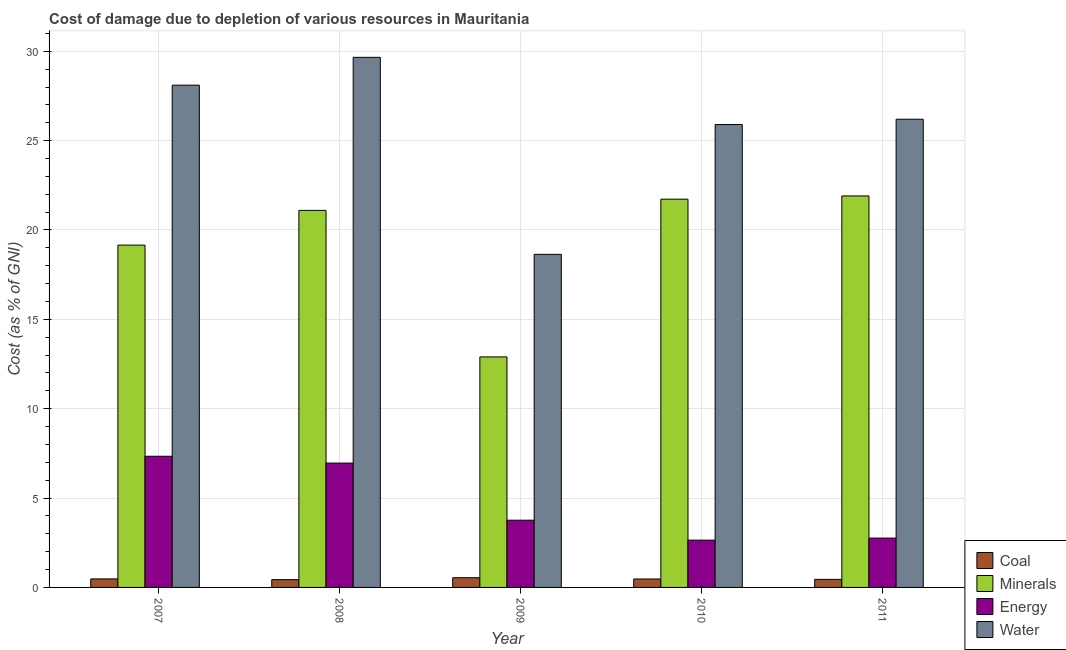How many different coloured bars are there?
Keep it short and to the point. 4. Are the number of bars on each tick of the X-axis equal?
Give a very brief answer. Yes. What is the label of the 1st group of bars from the left?
Your answer should be compact. 2007. In how many cases, is the number of bars for a given year not equal to the number of legend labels?
Provide a short and direct response. 0. What is the cost of damage due to depletion of energy in 2010?
Make the answer very short. 2.65. Across all years, what is the maximum cost of damage due to depletion of water?
Your response must be concise. 29.66. Across all years, what is the minimum cost of damage due to depletion of coal?
Your answer should be compact. 0.44. In which year was the cost of damage due to depletion of coal minimum?
Ensure brevity in your answer.  2008. What is the total cost of damage due to depletion of energy in the graph?
Give a very brief answer. 23.47. What is the difference between the cost of damage due to depletion of water in 2009 and that in 2010?
Provide a succinct answer. -7.26. What is the difference between the cost of damage due to depletion of energy in 2009 and the cost of damage due to depletion of minerals in 2007?
Your answer should be compact. -3.58. What is the average cost of damage due to depletion of energy per year?
Your response must be concise. 4.69. In the year 2008, what is the difference between the cost of damage due to depletion of minerals and cost of damage due to depletion of coal?
Your answer should be very brief. 0. In how many years, is the cost of damage due to depletion of minerals greater than 13 %?
Your answer should be compact. 4. What is the ratio of the cost of damage due to depletion of minerals in 2007 to that in 2010?
Offer a very short reply. 0.88. What is the difference between the highest and the second highest cost of damage due to depletion of minerals?
Your answer should be compact. 0.18. What is the difference between the highest and the lowest cost of damage due to depletion of energy?
Keep it short and to the point. 4.69. In how many years, is the cost of damage due to depletion of water greater than the average cost of damage due to depletion of water taken over all years?
Keep it short and to the point. 4. Is the sum of the cost of damage due to depletion of coal in 2009 and 2010 greater than the maximum cost of damage due to depletion of water across all years?
Keep it short and to the point. Yes. Is it the case that in every year, the sum of the cost of damage due to depletion of water and cost of damage due to depletion of energy is greater than the sum of cost of damage due to depletion of coal and cost of damage due to depletion of minerals?
Offer a very short reply. Yes. What does the 2nd bar from the left in 2011 represents?
Keep it short and to the point. Minerals. What does the 3rd bar from the right in 2011 represents?
Your answer should be compact. Minerals. How many bars are there?
Your response must be concise. 20. Are all the bars in the graph horizontal?
Provide a short and direct response. No. How many years are there in the graph?
Give a very brief answer. 5. What is the difference between two consecutive major ticks on the Y-axis?
Your answer should be very brief. 5. Does the graph contain grids?
Offer a very short reply. Yes. Where does the legend appear in the graph?
Keep it short and to the point. Bottom right. How many legend labels are there?
Offer a very short reply. 4. What is the title of the graph?
Offer a very short reply. Cost of damage due to depletion of various resources in Mauritania . What is the label or title of the Y-axis?
Offer a terse response. Cost (as % of GNI). What is the Cost (as % of GNI) of Coal in 2007?
Keep it short and to the point. 0.48. What is the Cost (as % of GNI) in Minerals in 2007?
Give a very brief answer. 19.15. What is the Cost (as % of GNI) in Energy in 2007?
Offer a terse response. 7.34. What is the Cost (as % of GNI) in Water in 2007?
Give a very brief answer. 28.1. What is the Cost (as % of GNI) in Coal in 2008?
Give a very brief answer. 0.44. What is the Cost (as % of GNI) of Minerals in 2008?
Keep it short and to the point. 21.1. What is the Cost (as % of GNI) in Energy in 2008?
Your response must be concise. 6.96. What is the Cost (as % of GNI) in Water in 2008?
Give a very brief answer. 29.66. What is the Cost (as % of GNI) of Coal in 2009?
Offer a very short reply. 0.54. What is the Cost (as % of GNI) in Minerals in 2009?
Keep it short and to the point. 12.9. What is the Cost (as % of GNI) in Energy in 2009?
Keep it short and to the point. 3.76. What is the Cost (as % of GNI) of Water in 2009?
Your answer should be compact. 18.64. What is the Cost (as % of GNI) of Coal in 2010?
Make the answer very short. 0.47. What is the Cost (as % of GNI) in Minerals in 2010?
Provide a short and direct response. 21.73. What is the Cost (as % of GNI) of Energy in 2010?
Provide a succinct answer. 2.65. What is the Cost (as % of GNI) of Water in 2010?
Provide a short and direct response. 25.9. What is the Cost (as % of GNI) of Coal in 2011?
Give a very brief answer. 0.45. What is the Cost (as % of GNI) in Minerals in 2011?
Your answer should be very brief. 21.91. What is the Cost (as % of GNI) of Energy in 2011?
Offer a very short reply. 2.76. What is the Cost (as % of GNI) in Water in 2011?
Your response must be concise. 26.2. Across all years, what is the maximum Cost (as % of GNI) in Coal?
Your answer should be very brief. 0.54. Across all years, what is the maximum Cost (as % of GNI) of Minerals?
Your answer should be compact. 21.91. Across all years, what is the maximum Cost (as % of GNI) in Energy?
Your answer should be compact. 7.34. Across all years, what is the maximum Cost (as % of GNI) in Water?
Offer a terse response. 29.66. Across all years, what is the minimum Cost (as % of GNI) of Coal?
Offer a terse response. 0.44. Across all years, what is the minimum Cost (as % of GNI) in Minerals?
Provide a short and direct response. 12.9. Across all years, what is the minimum Cost (as % of GNI) in Energy?
Your response must be concise. 2.65. Across all years, what is the minimum Cost (as % of GNI) of Water?
Your answer should be compact. 18.64. What is the total Cost (as % of GNI) of Coal in the graph?
Offer a terse response. 2.38. What is the total Cost (as % of GNI) in Minerals in the graph?
Provide a succinct answer. 96.78. What is the total Cost (as % of GNI) in Energy in the graph?
Keep it short and to the point. 23.47. What is the total Cost (as % of GNI) of Water in the graph?
Keep it short and to the point. 128.5. What is the difference between the Cost (as % of GNI) of Coal in 2007 and that in 2008?
Give a very brief answer. 0.04. What is the difference between the Cost (as % of GNI) in Minerals in 2007 and that in 2008?
Your answer should be compact. -1.95. What is the difference between the Cost (as % of GNI) in Energy in 2007 and that in 2008?
Give a very brief answer. 0.38. What is the difference between the Cost (as % of GNI) of Water in 2007 and that in 2008?
Your answer should be compact. -1.56. What is the difference between the Cost (as % of GNI) in Coal in 2007 and that in 2009?
Make the answer very short. -0.07. What is the difference between the Cost (as % of GNI) in Minerals in 2007 and that in 2009?
Your answer should be compact. 6.25. What is the difference between the Cost (as % of GNI) of Energy in 2007 and that in 2009?
Offer a terse response. 3.58. What is the difference between the Cost (as % of GNI) in Water in 2007 and that in 2009?
Your response must be concise. 9.47. What is the difference between the Cost (as % of GNI) of Coal in 2007 and that in 2010?
Your answer should be compact. 0. What is the difference between the Cost (as % of GNI) of Minerals in 2007 and that in 2010?
Give a very brief answer. -2.57. What is the difference between the Cost (as % of GNI) in Energy in 2007 and that in 2010?
Offer a terse response. 4.69. What is the difference between the Cost (as % of GNI) of Water in 2007 and that in 2010?
Ensure brevity in your answer.  2.2. What is the difference between the Cost (as % of GNI) of Coal in 2007 and that in 2011?
Your answer should be very brief. 0.03. What is the difference between the Cost (as % of GNI) of Minerals in 2007 and that in 2011?
Ensure brevity in your answer.  -2.75. What is the difference between the Cost (as % of GNI) of Energy in 2007 and that in 2011?
Ensure brevity in your answer.  4.58. What is the difference between the Cost (as % of GNI) in Water in 2007 and that in 2011?
Keep it short and to the point. 1.91. What is the difference between the Cost (as % of GNI) in Coal in 2008 and that in 2009?
Your response must be concise. -0.11. What is the difference between the Cost (as % of GNI) in Minerals in 2008 and that in 2009?
Make the answer very short. 8.2. What is the difference between the Cost (as % of GNI) of Energy in 2008 and that in 2009?
Your answer should be very brief. 3.2. What is the difference between the Cost (as % of GNI) in Water in 2008 and that in 2009?
Keep it short and to the point. 11.02. What is the difference between the Cost (as % of GNI) of Coal in 2008 and that in 2010?
Make the answer very short. -0.04. What is the difference between the Cost (as % of GNI) in Minerals in 2008 and that in 2010?
Provide a short and direct response. -0.63. What is the difference between the Cost (as % of GNI) in Energy in 2008 and that in 2010?
Your answer should be compact. 4.31. What is the difference between the Cost (as % of GNI) of Water in 2008 and that in 2010?
Your response must be concise. 3.76. What is the difference between the Cost (as % of GNI) of Coal in 2008 and that in 2011?
Your response must be concise. -0.02. What is the difference between the Cost (as % of GNI) of Minerals in 2008 and that in 2011?
Your answer should be very brief. -0.81. What is the difference between the Cost (as % of GNI) in Energy in 2008 and that in 2011?
Offer a very short reply. 4.2. What is the difference between the Cost (as % of GNI) in Water in 2008 and that in 2011?
Your answer should be very brief. 3.46. What is the difference between the Cost (as % of GNI) in Coal in 2009 and that in 2010?
Your answer should be compact. 0.07. What is the difference between the Cost (as % of GNI) of Minerals in 2009 and that in 2010?
Your response must be concise. -8.83. What is the difference between the Cost (as % of GNI) of Energy in 2009 and that in 2010?
Offer a very short reply. 1.12. What is the difference between the Cost (as % of GNI) of Water in 2009 and that in 2010?
Your response must be concise. -7.26. What is the difference between the Cost (as % of GNI) of Coal in 2009 and that in 2011?
Offer a very short reply. 0.09. What is the difference between the Cost (as % of GNI) of Minerals in 2009 and that in 2011?
Give a very brief answer. -9.01. What is the difference between the Cost (as % of GNI) of Water in 2009 and that in 2011?
Give a very brief answer. -7.56. What is the difference between the Cost (as % of GNI) of Coal in 2010 and that in 2011?
Provide a succinct answer. 0.02. What is the difference between the Cost (as % of GNI) in Minerals in 2010 and that in 2011?
Provide a succinct answer. -0.18. What is the difference between the Cost (as % of GNI) of Energy in 2010 and that in 2011?
Offer a very short reply. -0.11. What is the difference between the Cost (as % of GNI) in Water in 2010 and that in 2011?
Provide a short and direct response. -0.3. What is the difference between the Cost (as % of GNI) of Coal in 2007 and the Cost (as % of GNI) of Minerals in 2008?
Offer a very short reply. -20.62. What is the difference between the Cost (as % of GNI) in Coal in 2007 and the Cost (as % of GNI) in Energy in 2008?
Ensure brevity in your answer.  -6.48. What is the difference between the Cost (as % of GNI) of Coal in 2007 and the Cost (as % of GNI) of Water in 2008?
Ensure brevity in your answer.  -29.19. What is the difference between the Cost (as % of GNI) in Minerals in 2007 and the Cost (as % of GNI) in Energy in 2008?
Provide a succinct answer. 12.2. What is the difference between the Cost (as % of GNI) in Minerals in 2007 and the Cost (as % of GNI) in Water in 2008?
Ensure brevity in your answer.  -10.51. What is the difference between the Cost (as % of GNI) in Energy in 2007 and the Cost (as % of GNI) in Water in 2008?
Your answer should be compact. -22.32. What is the difference between the Cost (as % of GNI) of Coal in 2007 and the Cost (as % of GNI) of Minerals in 2009?
Give a very brief answer. -12.42. What is the difference between the Cost (as % of GNI) of Coal in 2007 and the Cost (as % of GNI) of Energy in 2009?
Your answer should be compact. -3.29. What is the difference between the Cost (as % of GNI) in Coal in 2007 and the Cost (as % of GNI) in Water in 2009?
Give a very brief answer. -18.16. What is the difference between the Cost (as % of GNI) in Minerals in 2007 and the Cost (as % of GNI) in Energy in 2009?
Make the answer very short. 15.39. What is the difference between the Cost (as % of GNI) in Minerals in 2007 and the Cost (as % of GNI) in Water in 2009?
Ensure brevity in your answer.  0.52. What is the difference between the Cost (as % of GNI) of Energy in 2007 and the Cost (as % of GNI) of Water in 2009?
Your answer should be compact. -11.3. What is the difference between the Cost (as % of GNI) in Coal in 2007 and the Cost (as % of GNI) in Minerals in 2010?
Make the answer very short. -21.25. What is the difference between the Cost (as % of GNI) in Coal in 2007 and the Cost (as % of GNI) in Energy in 2010?
Make the answer very short. -2.17. What is the difference between the Cost (as % of GNI) of Coal in 2007 and the Cost (as % of GNI) of Water in 2010?
Give a very brief answer. -25.42. What is the difference between the Cost (as % of GNI) in Minerals in 2007 and the Cost (as % of GNI) in Energy in 2010?
Provide a short and direct response. 16.51. What is the difference between the Cost (as % of GNI) in Minerals in 2007 and the Cost (as % of GNI) in Water in 2010?
Provide a short and direct response. -6.75. What is the difference between the Cost (as % of GNI) of Energy in 2007 and the Cost (as % of GNI) of Water in 2010?
Make the answer very short. -18.56. What is the difference between the Cost (as % of GNI) in Coal in 2007 and the Cost (as % of GNI) in Minerals in 2011?
Provide a short and direct response. -21.43. What is the difference between the Cost (as % of GNI) of Coal in 2007 and the Cost (as % of GNI) of Energy in 2011?
Provide a short and direct response. -2.28. What is the difference between the Cost (as % of GNI) of Coal in 2007 and the Cost (as % of GNI) of Water in 2011?
Provide a short and direct response. -25.72. What is the difference between the Cost (as % of GNI) in Minerals in 2007 and the Cost (as % of GNI) in Energy in 2011?
Make the answer very short. 16.39. What is the difference between the Cost (as % of GNI) of Minerals in 2007 and the Cost (as % of GNI) of Water in 2011?
Provide a short and direct response. -7.04. What is the difference between the Cost (as % of GNI) in Energy in 2007 and the Cost (as % of GNI) in Water in 2011?
Offer a very short reply. -18.86. What is the difference between the Cost (as % of GNI) in Coal in 2008 and the Cost (as % of GNI) in Minerals in 2009?
Give a very brief answer. -12.46. What is the difference between the Cost (as % of GNI) of Coal in 2008 and the Cost (as % of GNI) of Energy in 2009?
Give a very brief answer. -3.33. What is the difference between the Cost (as % of GNI) of Coal in 2008 and the Cost (as % of GNI) of Water in 2009?
Your answer should be very brief. -18.2. What is the difference between the Cost (as % of GNI) of Minerals in 2008 and the Cost (as % of GNI) of Energy in 2009?
Offer a very short reply. 17.34. What is the difference between the Cost (as % of GNI) of Minerals in 2008 and the Cost (as % of GNI) of Water in 2009?
Keep it short and to the point. 2.46. What is the difference between the Cost (as % of GNI) of Energy in 2008 and the Cost (as % of GNI) of Water in 2009?
Make the answer very short. -11.68. What is the difference between the Cost (as % of GNI) in Coal in 2008 and the Cost (as % of GNI) in Minerals in 2010?
Your answer should be compact. -21.29. What is the difference between the Cost (as % of GNI) in Coal in 2008 and the Cost (as % of GNI) in Energy in 2010?
Your answer should be very brief. -2.21. What is the difference between the Cost (as % of GNI) of Coal in 2008 and the Cost (as % of GNI) of Water in 2010?
Make the answer very short. -25.47. What is the difference between the Cost (as % of GNI) in Minerals in 2008 and the Cost (as % of GNI) in Energy in 2010?
Offer a terse response. 18.45. What is the difference between the Cost (as % of GNI) of Minerals in 2008 and the Cost (as % of GNI) of Water in 2010?
Keep it short and to the point. -4.8. What is the difference between the Cost (as % of GNI) of Energy in 2008 and the Cost (as % of GNI) of Water in 2010?
Give a very brief answer. -18.94. What is the difference between the Cost (as % of GNI) of Coal in 2008 and the Cost (as % of GNI) of Minerals in 2011?
Your answer should be compact. -21.47. What is the difference between the Cost (as % of GNI) in Coal in 2008 and the Cost (as % of GNI) in Energy in 2011?
Keep it short and to the point. -2.33. What is the difference between the Cost (as % of GNI) of Coal in 2008 and the Cost (as % of GNI) of Water in 2011?
Give a very brief answer. -25.76. What is the difference between the Cost (as % of GNI) in Minerals in 2008 and the Cost (as % of GNI) in Energy in 2011?
Provide a short and direct response. 18.34. What is the difference between the Cost (as % of GNI) of Minerals in 2008 and the Cost (as % of GNI) of Water in 2011?
Your answer should be very brief. -5.1. What is the difference between the Cost (as % of GNI) of Energy in 2008 and the Cost (as % of GNI) of Water in 2011?
Give a very brief answer. -19.24. What is the difference between the Cost (as % of GNI) of Coal in 2009 and the Cost (as % of GNI) of Minerals in 2010?
Offer a very short reply. -21.18. What is the difference between the Cost (as % of GNI) in Coal in 2009 and the Cost (as % of GNI) in Energy in 2010?
Your answer should be compact. -2.1. What is the difference between the Cost (as % of GNI) in Coal in 2009 and the Cost (as % of GNI) in Water in 2010?
Give a very brief answer. -25.36. What is the difference between the Cost (as % of GNI) of Minerals in 2009 and the Cost (as % of GNI) of Energy in 2010?
Make the answer very short. 10.25. What is the difference between the Cost (as % of GNI) of Minerals in 2009 and the Cost (as % of GNI) of Water in 2010?
Provide a short and direct response. -13. What is the difference between the Cost (as % of GNI) of Energy in 2009 and the Cost (as % of GNI) of Water in 2010?
Your response must be concise. -22.14. What is the difference between the Cost (as % of GNI) in Coal in 2009 and the Cost (as % of GNI) in Minerals in 2011?
Offer a very short reply. -21.36. What is the difference between the Cost (as % of GNI) of Coal in 2009 and the Cost (as % of GNI) of Energy in 2011?
Your answer should be very brief. -2.22. What is the difference between the Cost (as % of GNI) of Coal in 2009 and the Cost (as % of GNI) of Water in 2011?
Provide a short and direct response. -25.65. What is the difference between the Cost (as % of GNI) in Minerals in 2009 and the Cost (as % of GNI) in Energy in 2011?
Provide a succinct answer. 10.14. What is the difference between the Cost (as % of GNI) in Minerals in 2009 and the Cost (as % of GNI) in Water in 2011?
Provide a short and direct response. -13.3. What is the difference between the Cost (as % of GNI) in Energy in 2009 and the Cost (as % of GNI) in Water in 2011?
Offer a very short reply. -22.44. What is the difference between the Cost (as % of GNI) in Coal in 2010 and the Cost (as % of GNI) in Minerals in 2011?
Provide a short and direct response. -21.43. What is the difference between the Cost (as % of GNI) in Coal in 2010 and the Cost (as % of GNI) in Energy in 2011?
Make the answer very short. -2.29. What is the difference between the Cost (as % of GNI) of Coal in 2010 and the Cost (as % of GNI) of Water in 2011?
Provide a short and direct response. -25.73. What is the difference between the Cost (as % of GNI) in Minerals in 2010 and the Cost (as % of GNI) in Energy in 2011?
Provide a short and direct response. 18.96. What is the difference between the Cost (as % of GNI) in Minerals in 2010 and the Cost (as % of GNI) in Water in 2011?
Provide a short and direct response. -4.47. What is the difference between the Cost (as % of GNI) of Energy in 2010 and the Cost (as % of GNI) of Water in 2011?
Make the answer very short. -23.55. What is the average Cost (as % of GNI) in Coal per year?
Offer a terse response. 0.48. What is the average Cost (as % of GNI) of Minerals per year?
Provide a succinct answer. 19.36. What is the average Cost (as % of GNI) of Energy per year?
Your answer should be compact. 4.69. What is the average Cost (as % of GNI) in Water per year?
Make the answer very short. 25.7. In the year 2007, what is the difference between the Cost (as % of GNI) of Coal and Cost (as % of GNI) of Minerals?
Your response must be concise. -18.68. In the year 2007, what is the difference between the Cost (as % of GNI) of Coal and Cost (as % of GNI) of Energy?
Your response must be concise. -6.86. In the year 2007, what is the difference between the Cost (as % of GNI) in Coal and Cost (as % of GNI) in Water?
Ensure brevity in your answer.  -27.63. In the year 2007, what is the difference between the Cost (as % of GNI) in Minerals and Cost (as % of GNI) in Energy?
Make the answer very short. 11.81. In the year 2007, what is the difference between the Cost (as % of GNI) in Minerals and Cost (as % of GNI) in Water?
Make the answer very short. -8.95. In the year 2007, what is the difference between the Cost (as % of GNI) of Energy and Cost (as % of GNI) of Water?
Offer a very short reply. -20.77. In the year 2008, what is the difference between the Cost (as % of GNI) in Coal and Cost (as % of GNI) in Minerals?
Ensure brevity in your answer.  -20.66. In the year 2008, what is the difference between the Cost (as % of GNI) in Coal and Cost (as % of GNI) in Energy?
Offer a very short reply. -6.52. In the year 2008, what is the difference between the Cost (as % of GNI) in Coal and Cost (as % of GNI) in Water?
Provide a short and direct response. -29.23. In the year 2008, what is the difference between the Cost (as % of GNI) in Minerals and Cost (as % of GNI) in Energy?
Provide a short and direct response. 14.14. In the year 2008, what is the difference between the Cost (as % of GNI) in Minerals and Cost (as % of GNI) in Water?
Offer a terse response. -8.56. In the year 2008, what is the difference between the Cost (as % of GNI) in Energy and Cost (as % of GNI) in Water?
Your answer should be very brief. -22.7. In the year 2009, what is the difference between the Cost (as % of GNI) of Coal and Cost (as % of GNI) of Minerals?
Your answer should be very brief. -12.36. In the year 2009, what is the difference between the Cost (as % of GNI) in Coal and Cost (as % of GNI) in Energy?
Provide a short and direct response. -3.22. In the year 2009, what is the difference between the Cost (as % of GNI) of Coal and Cost (as % of GNI) of Water?
Offer a very short reply. -18.09. In the year 2009, what is the difference between the Cost (as % of GNI) of Minerals and Cost (as % of GNI) of Energy?
Provide a succinct answer. 9.14. In the year 2009, what is the difference between the Cost (as % of GNI) in Minerals and Cost (as % of GNI) in Water?
Keep it short and to the point. -5.74. In the year 2009, what is the difference between the Cost (as % of GNI) of Energy and Cost (as % of GNI) of Water?
Keep it short and to the point. -14.88. In the year 2010, what is the difference between the Cost (as % of GNI) of Coal and Cost (as % of GNI) of Minerals?
Provide a succinct answer. -21.25. In the year 2010, what is the difference between the Cost (as % of GNI) of Coal and Cost (as % of GNI) of Energy?
Give a very brief answer. -2.17. In the year 2010, what is the difference between the Cost (as % of GNI) of Coal and Cost (as % of GNI) of Water?
Your answer should be very brief. -25.43. In the year 2010, what is the difference between the Cost (as % of GNI) in Minerals and Cost (as % of GNI) in Energy?
Provide a short and direct response. 19.08. In the year 2010, what is the difference between the Cost (as % of GNI) in Minerals and Cost (as % of GNI) in Water?
Provide a short and direct response. -4.18. In the year 2010, what is the difference between the Cost (as % of GNI) of Energy and Cost (as % of GNI) of Water?
Keep it short and to the point. -23.25. In the year 2011, what is the difference between the Cost (as % of GNI) in Coal and Cost (as % of GNI) in Minerals?
Provide a succinct answer. -21.46. In the year 2011, what is the difference between the Cost (as % of GNI) in Coal and Cost (as % of GNI) in Energy?
Your response must be concise. -2.31. In the year 2011, what is the difference between the Cost (as % of GNI) in Coal and Cost (as % of GNI) in Water?
Make the answer very short. -25.75. In the year 2011, what is the difference between the Cost (as % of GNI) in Minerals and Cost (as % of GNI) in Energy?
Offer a terse response. 19.15. In the year 2011, what is the difference between the Cost (as % of GNI) in Minerals and Cost (as % of GNI) in Water?
Your answer should be compact. -4.29. In the year 2011, what is the difference between the Cost (as % of GNI) in Energy and Cost (as % of GNI) in Water?
Your response must be concise. -23.44. What is the ratio of the Cost (as % of GNI) in Coal in 2007 to that in 2008?
Your answer should be very brief. 1.09. What is the ratio of the Cost (as % of GNI) of Minerals in 2007 to that in 2008?
Offer a very short reply. 0.91. What is the ratio of the Cost (as % of GNI) of Energy in 2007 to that in 2008?
Keep it short and to the point. 1.05. What is the ratio of the Cost (as % of GNI) in Water in 2007 to that in 2008?
Offer a terse response. 0.95. What is the ratio of the Cost (as % of GNI) in Coal in 2007 to that in 2009?
Your answer should be compact. 0.87. What is the ratio of the Cost (as % of GNI) in Minerals in 2007 to that in 2009?
Your answer should be very brief. 1.48. What is the ratio of the Cost (as % of GNI) of Energy in 2007 to that in 2009?
Your answer should be compact. 1.95. What is the ratio of the Cost (as % of GNI) in Water in 2007 to that in 2009?
Ensure brevity in your answer.  1.51. What is the ratio of the Cost (as % of GNI) of Coal in 2007 to that in 2010?
Your response must be concise. 1.01. What is the ratio of the Cost (as % of GNI) of Minerals in 2007 to that in 2010?
Offer a terse response. 0.88. What is the ratio of the Cost (as % of GNI) in Energy in 2007 to that in 2010?
Offer a very short reply. 2.77. What is the ratio of the Cost (as % of GNI) in Water in 2007 to that in 2010?
Your answer should be compact. 1.09. What is the ratio of the Cost (as % of GNI) in Coal in 2007 to that in 2011?
Your answer should be compact. 1.06. What is the ratio of the Cost (as % of GNI) in Minerals in 2007 to that in 2011?
Ensure brevity in your answer.  0.87. What is the ratio of the Cost (as % of GNI) in Energy in 2007 to that in 2011?
Offer a terse response. 2.66. What is the ratio of the Cost (as % of GNI) of Water in 2007 to that in 2011?
Your response must be concise. 1.07. What is the ratio of the Cost (as % of GNI) in Coal in 2008 to that in 2009?
Provide a succinct answer. 0.8. What is the ratio of the Cost (as % of GNI) of Minerals in 2008 to that in 2009?
Keep it short and to the point. 1.64. What is the ratio of the Cost (as % of GNI) in Energy in 2008 to that in 2009?
Ensure brevity in your answer.  1.85. What is the ratio of the Cost (as % of GNI) of Water in 2008 to that in 2009?
Provide a short and direct response. 1.59. What is the ratio of the Cost (as % of GNI) in Coal in 2008 to that in 2010?
Make the answer very short. 0.92. What is the ratio of the Cost (as % of GNI) of Minerals in 2008 to that in 2010?
Your answer should be very brief. 0.97. What is the ratio of the Cost (as % of GNI) in Energy in 2008 to that in 2010?
Provide a short and direct response. 2.63. What is the ratio of the Cost (as % of GNI) of Water in 2008 to that in 2010?
Give a very brief answer. 1.15. What is the ratio of the Cost (as % of GNI) in Coal in 2008 to that in 2011?
Make the answer very short. 0.97. What is the ratio of the Cost (as % of GNI) of Minerals in 2008 to that in 2011?
Give a very brief answer. 0.96. What is the ratio of the Cost (as % of GNI) in Energy in 2008 to that in 2011?
Keep it short and to the point. 2.52. What is the ratio of the Cost (as % of GNI) of Water in 2008 to that in 2011?
Your answer should be very brief. 1.13. What is the ratio of the Cost (as % of GNI) in Coal in 2009 to that in 2010?
Ensure brevity in your answer.  1.15. What is the ratio of the Cost (as % of GNI) of Minerals in 2009 to that in 2010?
Make the answer very short. 0.59. What is the ratio of the Cost (as % of GNI) in Energy in 2009 to that in 2010?
Offer a very short reply. 1.42. What is the ratio of the Cost (as % of GNI) of Water in 2009 to that in 2010?
Provide a succinct answer. 0.72. What is the ratio of the Cost (as % of GNI) in Coal in 2009 to that in 2011?
Your response must be concise. 1.21. What is the ratio of the Cost (as % of GNI) in Minerals in 2009 to that in 2011?
Make the answer very short. 0.59. What is the ratio of the Cost (as % of GNI) of Energy in 2009 to that in 2011?
Provide a succinct answer. 1.36. What is the ratio of the Cost (as % of GNI) in Water in 2009 to that in 2011?
Keep it short and to the point. 0.71. What is the ratio of the Cost (as % of GNI) in Coal in 2010 to that in 2011?
Ensure brevity in your answer.  1.05. What is the ratio of the Cost (as % of GNI) in Minerals in 2010 to that in 2011?
Offer a terse response. 0.99. What is the ratio of the Cost (as % of GNI) of Energy in 2010 to that in 2011?
Offer a very short reply. 0.96. What is the difference between the highest and the second highest Cost (as % of GNI) in Coal?
Your answer should be compact. 0.07. What is the difference between the highest and the second highest Cost (as % of GNI) in Minerals?
Ensure brevity in your answer.  0.18. What is the difference between the highest and the second highest Cost (as % of GNI) of Energy?
Provide a short and direct response. 0.38. What is the difference between the highest and the second highest Cost (as % of GNI) in Water?
Keep it short and to the point. 1.56. What is the difference between the highest and the lowest Cost (as % of GNI) of Coal?
Keep it short and to the point. 0.11. What is the difference between the highest and the lowest Cost (as % of GNI) in Minerals?
Offer a terse response. 9.01. What is the difference between the highest and the lowest Cost (as % of GNI) of Energy?
Offer a very short reply. 4.69. What is the difference between the highest and the lowest Cost (as % of GNI) in Water?
Your response must be concise. 11.02. 